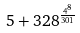<formula> <loc_0><loc_0><loc_500><loc_500>5 + 3 2 8 ^ { \frac { 4 ^ { 8 } } { 3 0 1 } }</formula> 